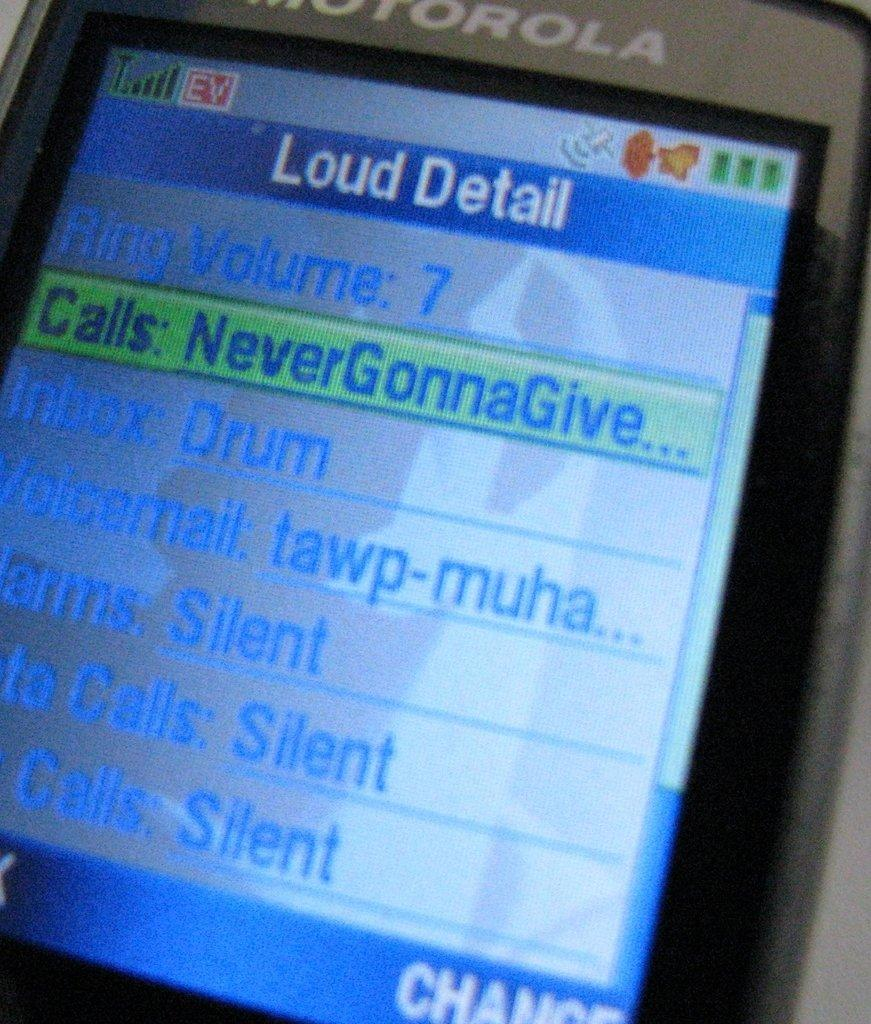What is the main subject of the image? The main subject of the image is a screen of a mobile phone. Can you describe what is displayed on the screen of the mobile phone? The details of what is displayed on the screen are not provided in the facts. What type of representative can be seen working in the field in the image? There is no representative or field present in the image; it is a picture of a screen of a mobile phone. How many pins are visible on the screen of the mobile phone in the image? The number of pins visible on the screen of the mobile phone is not mentioned in the facts. 